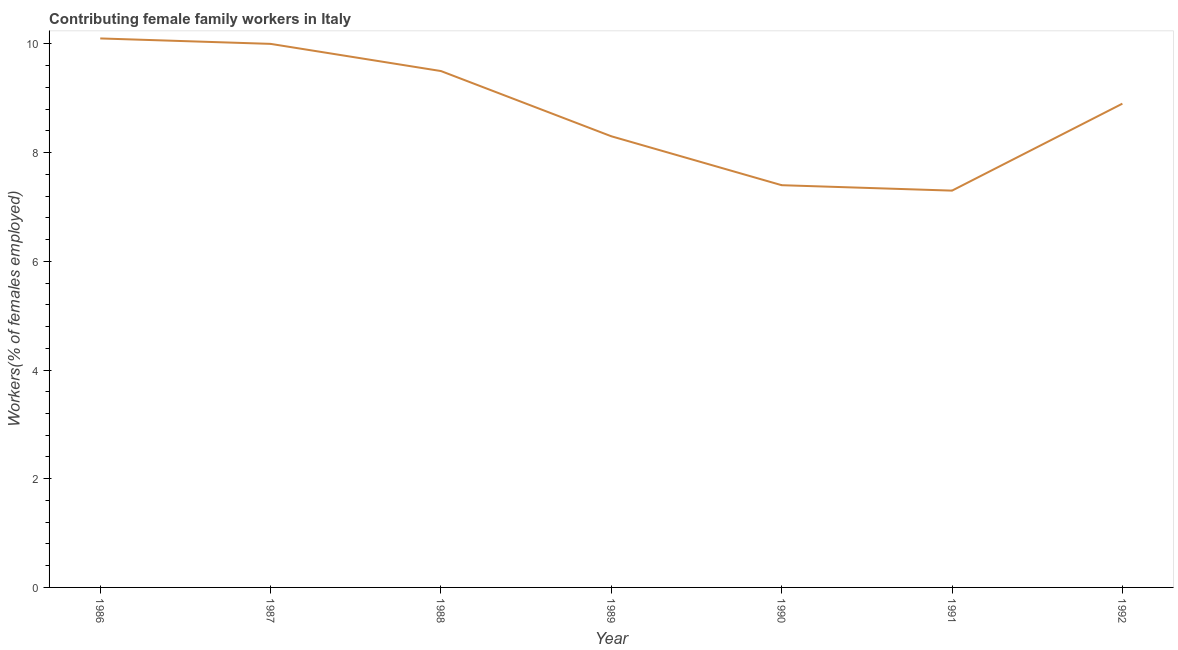What is the contributing female family workers in 1986?
Provide a short and direct response. 10.1. Across all years, what is the maximum contributing female family workers?
Your answer should be compact. 10.1. Across all years, what is the minimum contributing female family workers?
Your response must be concise. 7.3. In which year was the contributing female family workers maximum?
Your answer should be compact. 1986. What is the sum of the contributing female family workers?
Give a very brief answer. 61.5. What is the difference between the contributing female family workers in 1986 and 1987?
Make the answer very short. 0.1. What is the average contributing female family workers per year?
Offer a terse response. 8.79. What is the median contributing female family workers?
Your response must be concise. 8.9. Do a majority of the years between 1992 and 1991 (inclusive) have contributing female family workers greater than 5.2 %?
Make the answer very short. No. What is the ratio of the contributing female family workers in 1990 to that in 1992?
Your response must be concise. 0.83. Is the contributing female family workers in 1988 less than that in 1989?
Provide a succinct answer. No. Is the difference between the contributing female family workers in 1986 and 1987 greater than the difference between any two years?
Offer a very short reply. No. What is the difference between the highest and the second highest contributing female family workers?
Provide a succinct answer. 0.1. What is the difference between the highest and the lowest contributing female family workers?
Your answer should be very brief. 2.8. In how many years, is the contributing female family workers greater than the average contributing female family workers taken over all years?
Provide a succinct answer. 4. Does the contributing female family workers monotonically increase over the years?
Make the answer very short. No. How many lines are there?
Ensure brevity in your answer.  1. Are the values on the major ticks of Y-axis written in scientific E-notation?
Your answer should be very brief. No. What is the title of the graph?
Ensure brevity in your answer.  Contributing female family workers in Italy. What is the label or title of the X-axis?
Provide a succinct answer. Year. What is the label or title of the Y-axis?
Offer a very short reply. Workers(% of females employed). What is the Workers(% of females employed) in 1986?
Provide a succinct answer. 10.1. What is the Workers(% of females employed) in 1989?
Ensure brevity in your answer.  8.3. What is the Workers(% of females employed) in 1990?
Offer a terse response. 7.4. What is the Workers(% of females employed) in 1991?
Your answer should be very brief. 7.3. What is the Workers(% of females employed) of 1992?
Make the answer very short. 8.9. What is the difference between the Workers(% of females employed) in 1986 and 1989?
Offer a very short reply. 1.8. What is the difference between the Workers(% of females employed) in 1986 and 1990?
Make the answer very short. 2.7. What is the difference between the Workers(% of females employed) in 1986 and 1991?
Your answer should be compact. 2.8. What is the difference between the Workers(% of females employed) in 1986 and 1992?
Offer a terse response. 1.2. What is the difference between the Workers(% of females employed) in 1987 and 1988?
Make the answer very short. 0.5. What is the difference between the Workers(% of females employed) in 1987 and 1990?
Make the answer very short. 2.6. What is the difference between the Workers(% of females employed) in 1987 and 1991?
Offer a very short reply. 2.7. What is the difference between the Workers(% of females employed) in 1988 and 1989?
Your answer should be compact. 1.2. What is the difference between the Workers(% of females employed) in 1988 and 1992?
Make the answer very short. 0.6. What is the difference between the Workers(% of females employed) in 1990 and 1991?
Your answer should be very brief. 0.1. What is the ratio of the Workers(% of females employed) in 1986 to that in 1988?
Give a very brief answer. 1.06. What is the ratio of the Workers(% of females employed) in 1986 to that in 1989?
Your answer should be compact. 1.22. What is the ratio of the Workers(% of females employed) in 1986 to that in 1990?
Make the answer very short. 1.36. What is the ratio of the Workers(% of females employed) in 1986 to that in 1991?
Offer a very short reply. 1.38. What is the ratio of the Workers(% of females employed) in 1986 to that in 1992?
Give a very brief answer. 1.14. What is the ratio of the Workers(% of females employed) in 1987 to that in 1988?
Keep it short and to the point. 1.05. What is the ratio of the Workers(% of females employed) in 1987 to that in 1989?
Make the answer very short. 1.21. What is the ratio of the Workers(% of females employed) in 1987 to that in 1990?
Your answer should be very brief. 1.35. What is the ratio of the Workers(% of females employed) in 1987 to that in 1991?
Provide a succinct answer. 1.37. What is the ratio of the Workers(% of females employed) in 1987 to that in 1992?
Make the answer very short. 1.12. What is the ratio of the Workers(% of females employed) in 1988 to that in 1989?
Provide a short and direct response. 1.15. What is the ratio of the Workers(% of females employed) in 1988 to that in 1990?
Your answer should be compact. 1.28. What is the ratio of the Workers(% of females employed) in 1988 to that in 1991?
Offer a very short reply. 1.3. What is the ratio of the Workers(% of females employed) in 1988 to that in 1992?
Make the answer very short. 1.07. What is the ratio of the Workers(% of females employed) in 1989 to that in 1990?
Provide a short and direct response. 1.12. What is the ratio of the Workers(% of females employed) in 1989 to that in 1991?
Offer a very short reply. 1.14. What is the ratio of the Workers(% of females employed) in 1989 to that in 1992?
Give a very brief answer. 0.93. What is the ratio of the Workers(% of females employed) in 1990 to that in 1992?
Provide a short and direct response. 0.83. What is the ratio of the Workers(% of females employed) in 1991 to that in 1992?
Provide a succinct answer. 0.82. 